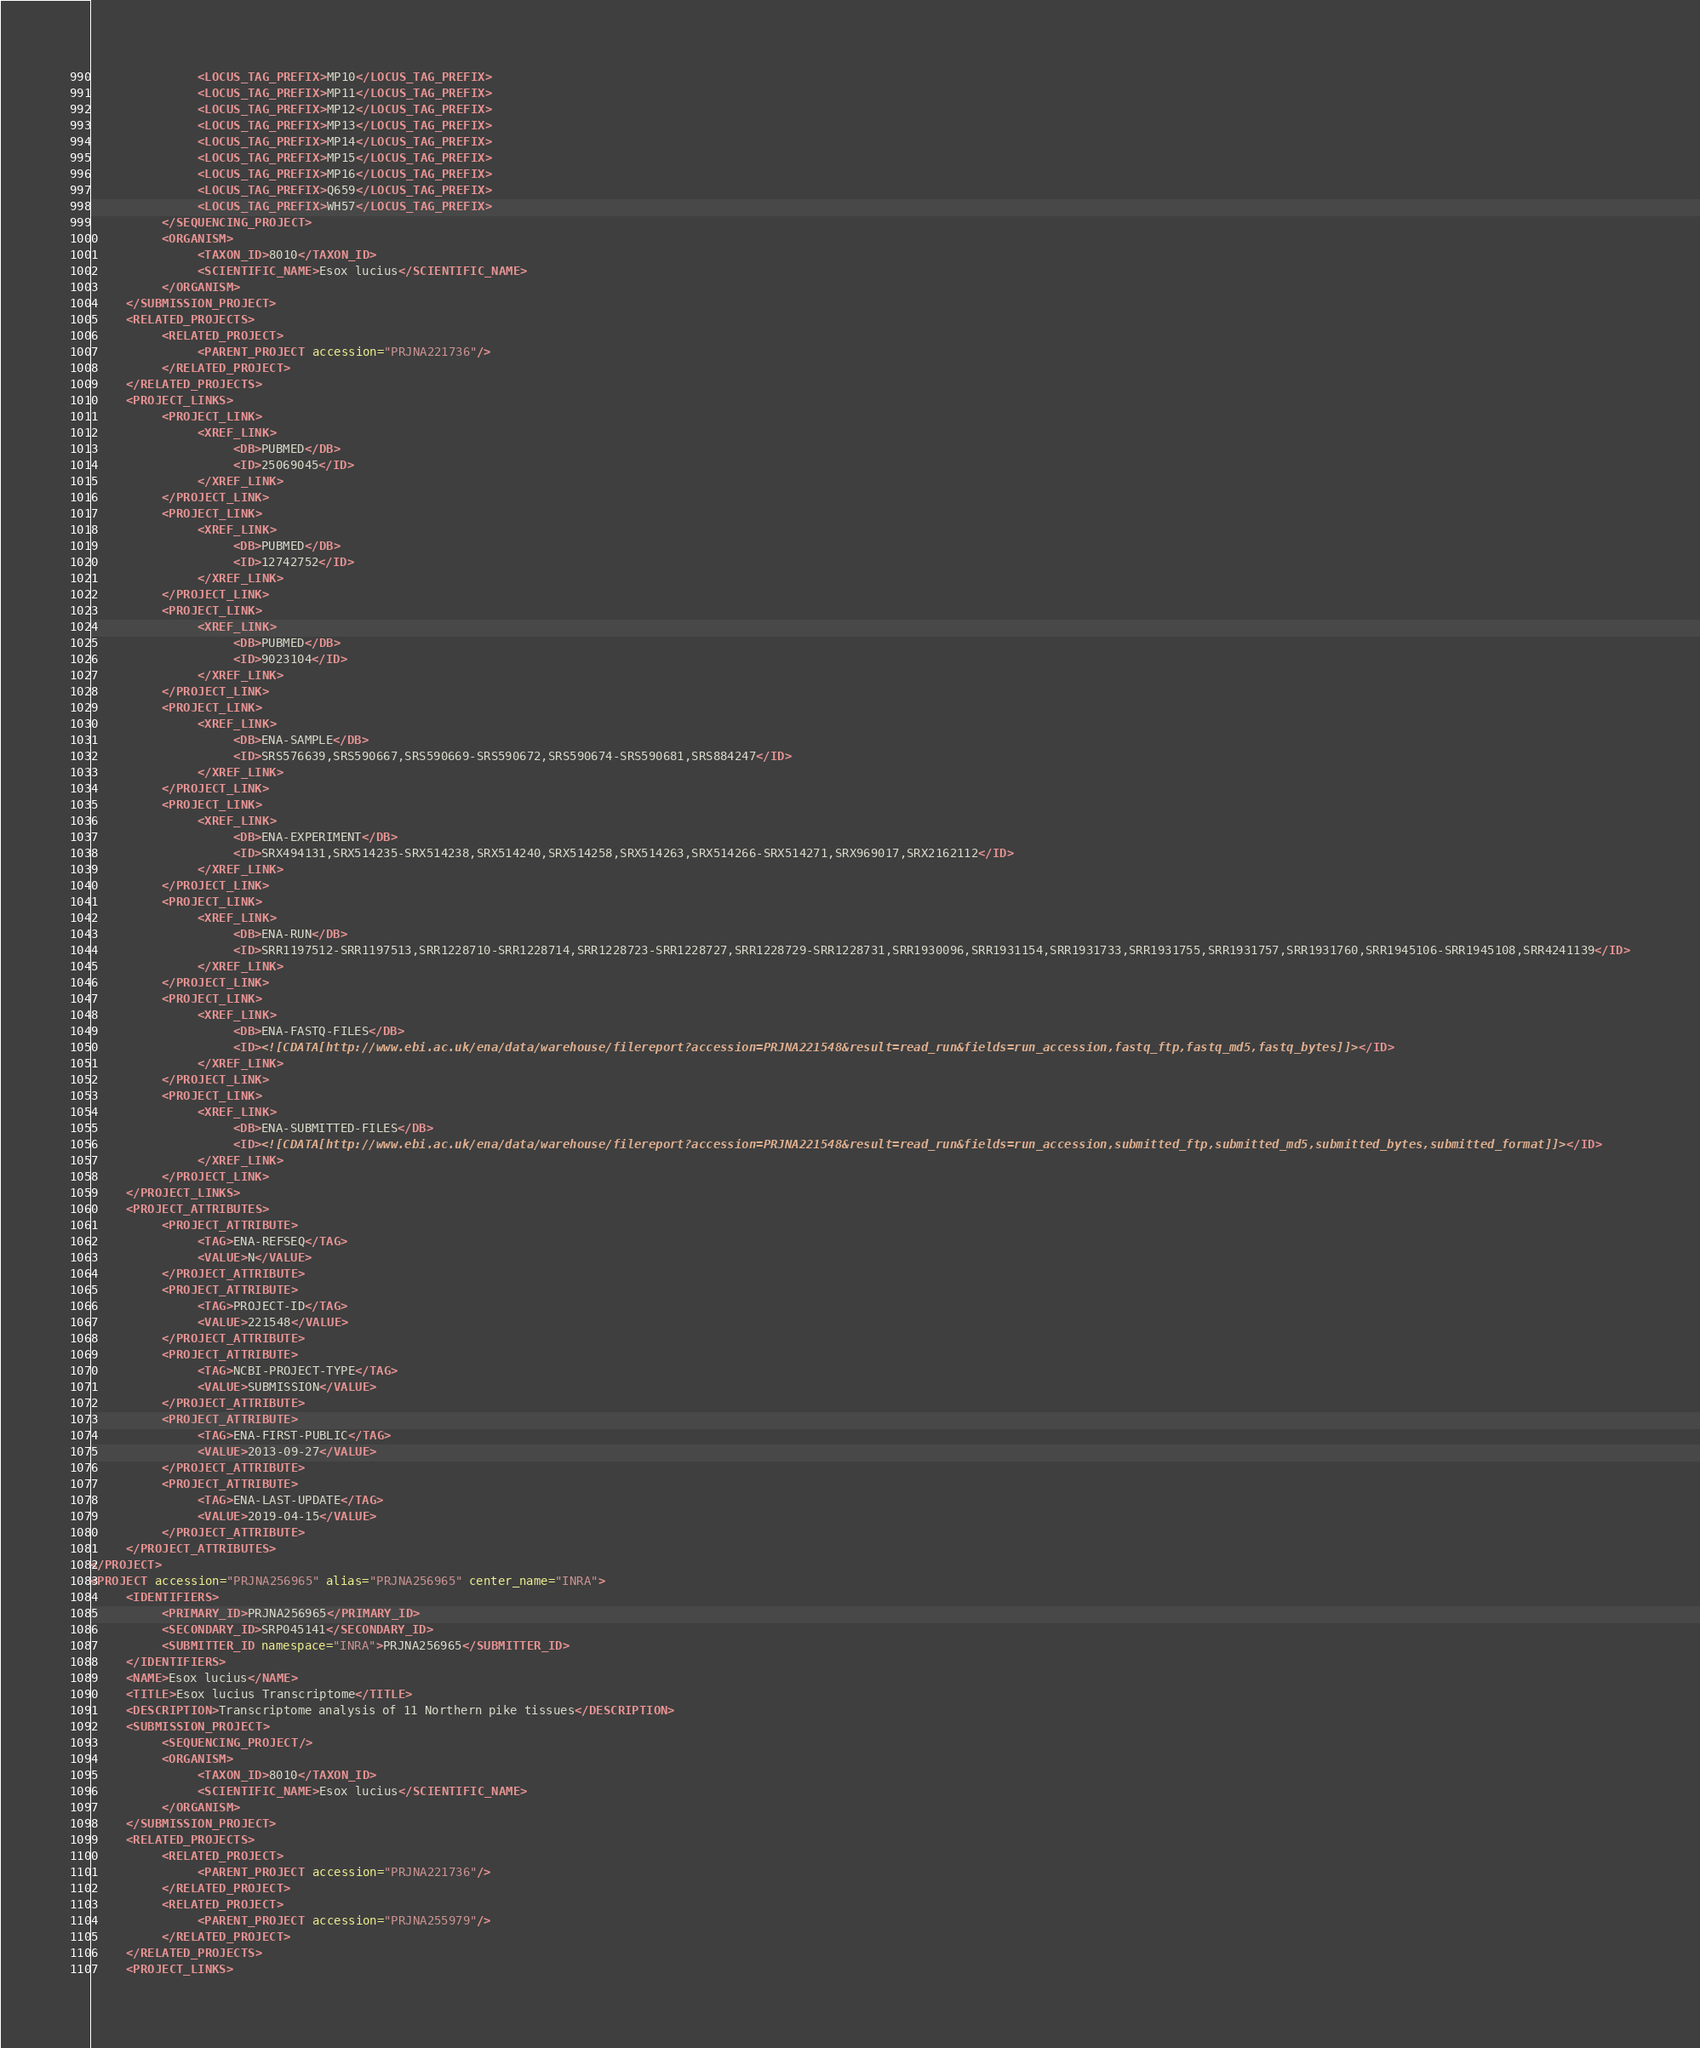<code> <loc_0><loc_0><loc_500><loc_500><_XML_>               <LOCUS_TAG_PREFIX>MP10</LOCUS_TAG_PREFIX>
               <LOCUS_TAG_PREFIX>MP11</LOCUS_TAG_PREFIX>
               <LOCUS_TAG_PREFIX>MP12</LOCUS_TAG_PREFIX>
               <LOCUS_TAG_PREFIX>MP13</LOCUS_TAG_PREFIX>
               <LOCUS_TAG_PREFIX>MP14</LOCUS_TAG_PREFIX>
               <LOCUS_TAG_PREFIX>MP15</LOCUS_TAG_PREFIX>
               <LOCUS_TAG_PREFIX>MP16</LOCUS_TAG_PREFIX>
               <LOCUS_TAG_PREFIX>Q659</LOCUS_TAG_PREFIX>
               <LOCUS_TAG_PREFIX>WH57</LOCUS_TAG_PREFIX>
          </SEQUENCING_PROJECT>
          <ORGANISM>
               <TAXON_ID>8010</TAXON_ID>
               <SCIENTIFIC_NAME>Esox lucius</SCIENTIFIC_NAME>
          </ORGANISM>
     </SUBMISSION_PROJECT>
     <RELATED_PROJECTS>
          <RELATED_PROJECT>
               <PARENT_PROJECT accession="PRJNA221736"/>
          </RELATED_PROJECT>
     </RELATED_PROJECTS>
     <PROJECT_LINKS>
          <PROJECT_LINK>
               <XREF_LINK>
                    <DB>PUBMED</DB>
                    <ID>25069045</ID>
               </XREF_LINK>
          </PROJECT_LINK>
          <PROJECT_LINK>
               <XREF_LINK>
                    <DB>PUBMED</DB>
                    <ID>12742752</ID>
               </XREF_LINK>
          </PROJECT_LINK>
          <PROJECT_LINK>
               <XREF_LINK>
                    <DB>PUBMED</DB>
                    <ID>9023104</ID>
               </XREF_LINK>
          </PROJECT_LINK>
          <PROJECT_LINK>
               <XREF_LINK>
                    <DB>ENA-SAMPLE</DB>
                    <ID>SRS576639,SRS590667,SRS590669-SRS590672,SRS590674-SRS590681,SRS884247</ID>
               </XREF_LINK>
          </PROJECT_LINK>
          <PROJECT_LINK>
               <XREF_LINK>
                    <DB>ENA-EXPERIMENT</DB>
                    <ID>SRX494131,SRX514235-SRX514238,SRX514240,SRX514258,SRX514263,SRX514266-SRX514271,SRX969017,SRX2162112</ID>
               </XREF_LINK>
          </PROJECT_LINK>
          <PROJECT_LINK>
               <XREF_LINK>
                    <DB>ENA-RUN</DB>
                    <ID>SRR1197512-SRR1197513,SRR1228710-SRR1228714,SRR1228723-SRR1228727,SRR1228729-SRR1228731,SRR1930096,SRR1931154,SRR1931733,SRR1931755,SRR1931757,SRR1931760,SRR1945106-SRR1945108,SRR4241139</ID>
               </XREF_LINK>
          </PROJECT_LINK>
          <PROJECT_LINK>
               <XREF_LINK>
                    <DB>ENA-FASTQ-FILES</DB>
                    <ID><![CDATA[http://www.ebi.ac.uk/ena/data/warehouse/filereport?accession=PRJNA221548&result=read_run&fields=run_accession,fastq_ftp,fastq_md5,fastq_bytes]]></ID>
               </XREF_LINK>
          </PROJECT_LINK>
          <PROJECT_LINK>
               <XREF_LINK>
                    <DB>ENA-SUBMITTED-FILES</DB>
                    <ID><![CDATA[http://www.ebi.ac.uk/ena/data/warehouse/filereport?accession=PRJNA221548&result=read_run&fields=run_accession,submitted_ftp,submitted_md5,submitted_bytes,submitted_format]]></ID>
               </XREF_LINK>
          </PROJECT_LINK>
     </PROJECT_LINKS>
     <PROJECT_ATTRIBUTES>
          <PROJECT_ATTRIBUTE>
               <TAG>ENA-REFSEQ</TAG>
               <VALUE>N</VALUE>
          </PROJECT_ATTRIBUTE>
          <PROJECT_ATTRIBUTE>
               <TAG>PROJECT-ID</TAG>
               <VALUE>221548</VALUE>
          </PROJECT_ATTRIBUTE>
          <PROJECT_ATTRIBUTE>
               <TAG>NCBI-PROJECT-TYPE</TAG>
               <VALUE>SUBMISSION</VALUE>
          </PROJECT_ATTRIBUTE>
          <PROJECT_ATTRIBUTE>
               <TAG>ENA-FIRST-PUBLIC</TAG>
               <VALUE>2013-09-27</VALUE>
          </PROJECT_ATTRIBUTE>
          <PROJECT_ATTRIBUTE>
               <TAG>ENA-LAST-UPDATE</TAG>
               <VALUE>2019-04-15</VALUE>
          </PROJECT_ATTRIBUTE>
     </PROJECT_ATTRIBUTES>
</PROJECT>
<PROJECT accession="PRJNA256965" alias="PRJNA256965" center_name="INRA">
     <IDENTIFIERS>
          <PRIMARY_ID>PRJNA256965</PRIMARY_ID>
          <SECONDARY_ID>SRP045141</SECONDARY_ID>
          <SUBMITTER_ID namespace="INRA">PRJNA256965</SUBMITTER_ID>
     </IDENTIFIERS>
     <NAME>Esox lucius</NAME>
     <TITLE>Esox lucius Transcriptome</TITLE>
     <DESCRIPTION>Transcriptome analysis of 11 Northern pike tissues</DESCRIPTION>
     <SUBMISSION_PROJECT>
          <SEQUENCING_PROJECT/>
          <ORGANISM>
               <TAXON_ID>8010</TAXON_ID>
               <SCIENTIFIC_NAME>Esox lucius</SCIENTIFIC_NAME>
          </ORGANISM>
     </SUBMISSION_PROJECT>
     <RELATED_PROJECTS>
          <RELATED_PROJECT>
               <PARENT_PROJECT accession="PRJNA221736"/>
          </RELATED_PROJECT>
          <RELATED_PROJECT>
               <PARENT_PROJECT accession="PRJNA255979"/>
          </RELATED_PROJECT>
     </RELATED_PROJECTS>
     <PROJECT_LINKS></code> 